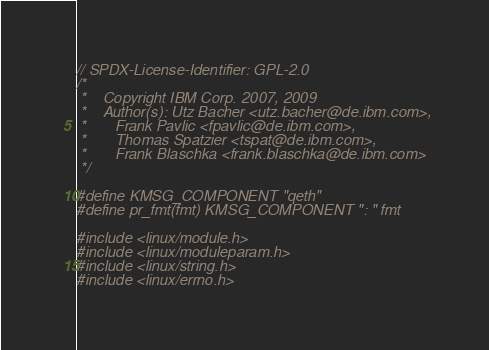<code> <loc_0><loc_0><loc_500><loc_500><_C_>// SPDX-License-Identifier: GPL-2.0
/*
 *    Copyright IBM Corp. 2007, 2009
 *    Author(s): Utz Bacher <utz.bacher@de.ibm.com>,
 *		 Frank Pavlic <fpavlic@de.ibm.com>,
 *		 Thomas Spatzier <tspat@de.ibm.com>,
 *		 Frank Blaschka <frank.blaschka@de.ibm.com>
 */

#define KMSG_COMPONENT "qeth"
#define pr_fmt(fmt) KMSG_COMPONENT ": " fmt

#include <linux/module.h>
#include <linux/moduleparam.h>
#include <linux/string.h>
#include <linux/errno.h></code> 